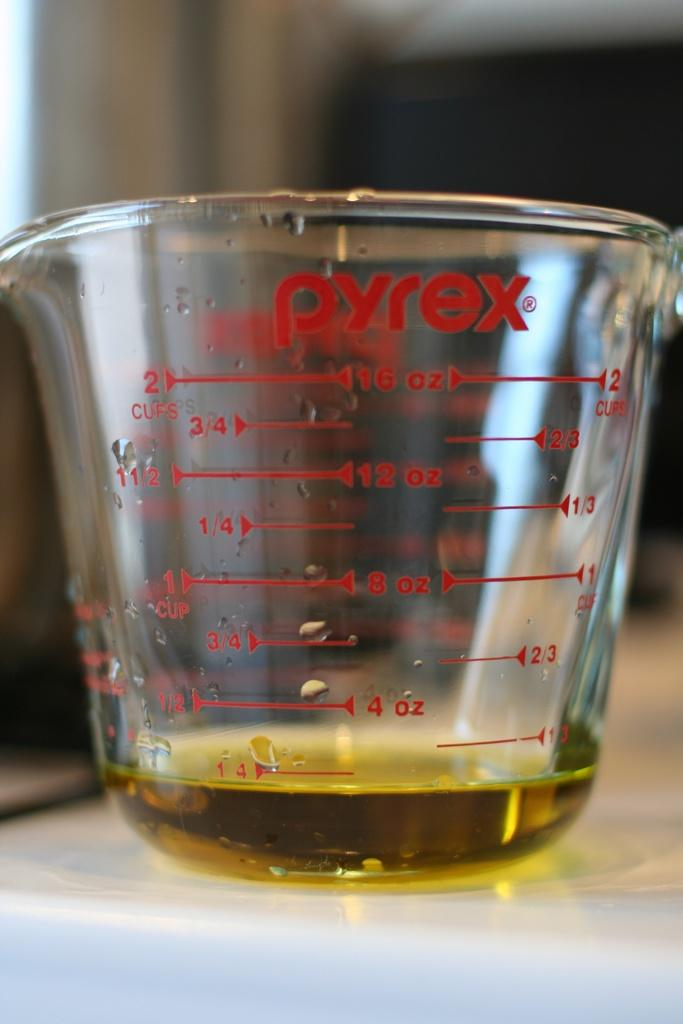<image>
Summarize the visual content of the image. A Pyrex measuring cup can measure up to 2 cups of liquid. 